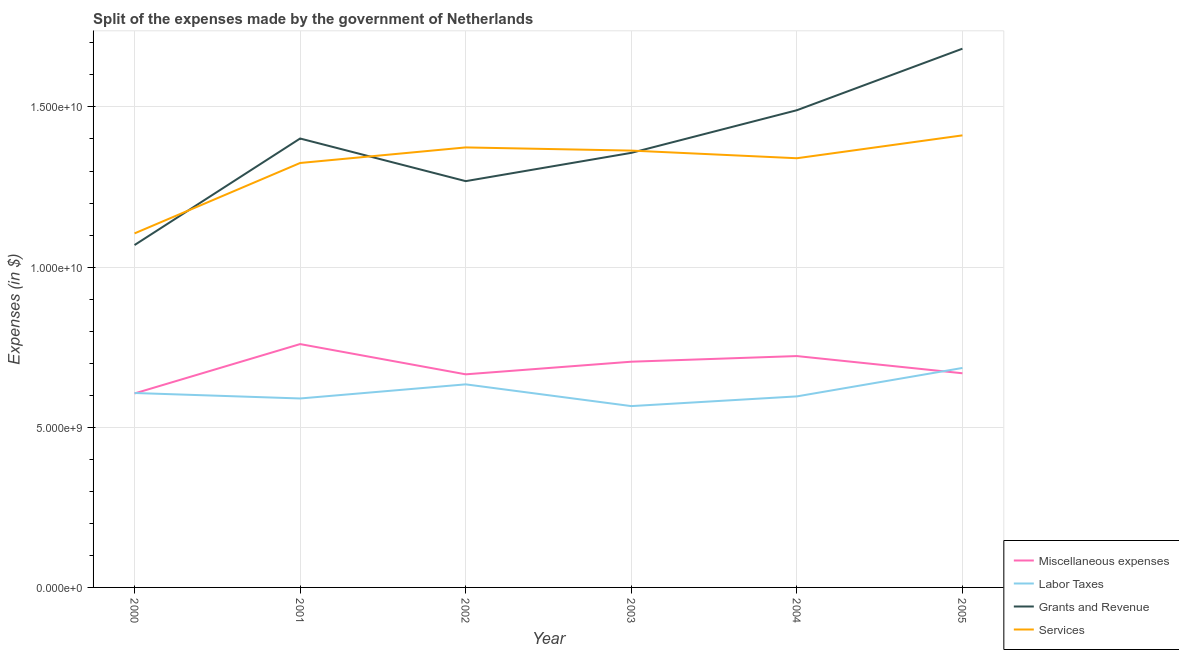Does the line corresponding to amount spent on labor taxes intersect with the line corresponding to amount spent on grants and revenue?
Provide a short and direct response. No. What is the amount spent on grants and revenue in 2005?
Your response must be concise. 1.68e+1. Across all years, what is the maximum amount spent on labor taxes?
Offer a very short reply. 6.85e+09. Across all years, what is the minimum amount spent on services?
Offer a terse response. 1.11e+1. What is the total amount spent on miscellaneous expenses in the graph?
Give a very brief answer. 4.13e+1. What is the difference between the amount spent on miscellaneous expenses in 2001 and that in 2002?
Keep it short and to the point. 9.44e+08. What is the difference between the amount spent on services in 2001 and the amount spent on miscellaneous expenses in 2003?
Offer a very short reply. 6.20e+09. What is the average amount spent on grants and revenue per year?
Keep it short and to the point. 1.38e+1. In the year 2003, what is the difference between the amount spent on labor taxes and amount spent on grants and revenue?
Make the answer very short. -7.91e+09. In how many years, is the amount spent on grants and revenue greater than 11000000000 $?
Your answer should be very brief. 5. What is the ratio of the amount spent on grants and revenue in 2001 to that in 2003?
Make the answer very short. 1.03. Is the amount spent on miscellaneous expenses in 2001 less than that in 2004?
Make the answer very short. No. What is the difference between the highest and the second highest amount spent on grants and revenue?
Make the answer very short. 1.92e+09. What is the difference between the highest and the lowest amount spent on grants and revenue?
Offer a terse response. 6.13e+09. Is the sum of the amount spent on labor taxes in 2001 and 2002 greater than the maximum amount spent on services across all years?
Provide a short and direct response. No. Is it the case that in every year, the sum of the amount spent on services and amount spent on grants and revenue is greater than the sum of amount spent on miscellaneous expenses and amount spent on labor taxes?
Give a very brief answer. Yes. Is it the case that in every year, the sum of the amount spent on miscellaneous expenses and amount spent on labor taxes is greater than the amount spent on grants and revenue?
Give a very brief answer. No. Does the graph contain any zero values?
Make the answer very short. No. What is the title of the graph?
Make the answer very short. Split of the expenses made by the government of Netherlands. Does "Belgium" appear as one of the legend labels in the graph?
Ensure brevity in your answer.  No. What is the label or title of the X-axis?
Your answer should be compact. Year. What is the label or title of the Y-axis?
Your response must be concise. Expenses (in $). What is the Expenses (in $) of Miscellaneous expenses in 2000?
Provide a short and direct response. 6.06e+09. What is the Expenses (in $) of Labor Taxes in 2000?
Your answer should be very brief. 6.07e+09. What is the Expenses (in $) in Grants and Revenue in 2000?
Offer a terse response. 1.07e+1. What is the Expenses (in $) of Services in 2000?
Offer a terse response. 1.11e+1. What is the Expenses (in $) in Miscellaneous expenses in 2001?
Your answer should be very brief. 7.60e+09. What is the Expenses (in $) of Labor Taxes in 2001?
Your answer should be compact. 5.90e+09. What is the Expenses (in $) of Grants and Revenue in 2001?
Offer a terse response. 1.40e+1. What is the Expenses (in $) of Services in 2001?
Ensure brevity in your answer.  1.33e+1. What is the Expenses (in $) in Miscellaneous expenses in 2002?
Provide a succinct answer. 6.65e+09. What is the Expenses (in $) of Labor Taxes in 2002?
Offer a terse response. 6.34e+09. What is the Expenses (in $) of Grants and Revenue in 2002?
Make the answer very short. 1.27e+1. What is the Expenses (in $) in Services in 2002?
Provide a short and direct response. 1.37e+1. What is the Expenses (in $) in Miscellaneous expenses in 2003?
Your response must be concise. 7.05e+09. What is the Expenses (in $) in Labor Taxes in 2003?
Give a very brief answer. 5.66e+09. What is the Expenses (in $) of Grants and Revenue in 2003?
Make the answer very short. 1.36e+1. What is the Expenses (in $) in Services in 2003?
Provide a succinct answer. 1.36e+1. What is the Expenses (in $) in Miscellaneous expenses in 2004?
Make the answer very short. 7.22e+09. What is the Expenses (in $) in Labor Taxes in 2004?
Provide a succinct answer. 5.96e+09. What is the Expenses (in $) of Grants and Revenue in 2004?
Your answer should be very brief. 1.49e+1. What is the Expenses (in $) of Services in 2004?
Keep it short and to the point. 1.34e+1. What is the Expenses (in $) in Miscellaneous expenses in 2005?
Your response must be concise. 6.69e+09. What is the Expenses (in $) in Labor Taxes in 2005?
Provide a succinct answer. 6.85e+09. What is the Expenses (in $) in Grants and Revenue in 2005?
Your response must be concise. 1.68e+1. What is the Expenses (in $) in Services in 2005?
Offer a terse response. 1.41e+1. Across all years, what is the maximum Expenses (in $) of Miscellaneous expenses?
Ensure brevity in your answer.  7.60e+09. Across all years, what is the maximum Expenses (in $) in Labor Taxes?
Ensure brevity in your answer.  6.85e+09. Across all years, what is the maximum Expenses (in $) of Grants and Revenue?
Your answer should be compact. 1.68e+1. Across all years, what is the maximum Expenses (in $) of Services?
Make the answer very short. 1.41e+1. Across all years, what is the minimum Expenses (in $) in Miscellaneous expenses?
Your answer should be very brief. 6.06e+09. Across all years, what is the minimum Expenses (in $) of Labor Taxes?
Keep it short and to the point. 5.66e+09. Across all years, what is the minimum Expenses (in $) in Grants and Revenue?
Provide a short and direct response. 1.07e+1. Across all years, what is the minimum Expenses (in $) of Services?
Provide a short and direct response. 1.11e+1. What is the total Expenses (in $) in Miscellaneous expenses in the graph?
Provide a succinct answer. 4.13e+1. What is the total Expenses (in $) of Labor Taxes in the graph?
Offer a terse response. 3.68e+1. What is the total Expenses (in $) of Grants and Revenue in the graph?
Offer a terse response. 8.27e+1. What is the total Expenses (in $) in Services in the graph?
Your answer should be compact. 7.92e+1. What is the difference between the Expenses (in $) of Miscellaneous expenses in 2000 and that in 2001?
Your answer should be very brief. -1.54e+09. What is the difference between the Expenses (in $) of Labor Taxes in 2000 and that in 2001?
Your answer should be very brief. 1.71e+08. What is the difference between the Expenses (in $) in Grants and Revenue in 2000 and that in 2001?
Provide a short and direct response. -3.33e+09. What is the difference between the Expenses (in $) of Services in 2000 and that in 2001?
Offer a very short reply. -2.20e+09. What is the difference between the Expenses (in $) of Miscellaneous expenses in 2000 and that in 2002?
Offer a terse response. -5.97e+08. What is the difference between the Expenses (in $) in Labor Taxes in 2000 and that in 2002?
Provide a short and direct response. -2.70e+08. What is the difference between the Expenses (in $) in Grants and Revenue in 2000 and that in 2002?
Offer a terse response. -2.00e+09. What is the difference between the Expenses (in $) in Services in 2000 and that in 2002?
Provide a succinct answer. -2.68e+09. What is the difference between the Expenses (in $) in Miscellaneous expenses in 2000 and that in 2003?
Offer a very short reply. -9.91e+08. What is the difference between the Expenses (in $) in Labor Taxes in 2000 and that in 2003?
Ensure brevity in your answer.  4.09e+08. What is the difference between the Expenses (in $) in Grants and Revenue in 2000 and that in 2003?
Your answer should be very brief. -2.88e+09. What is the difference between the Expenses (in $) of Services in 2000 and that in 2003?
Offer a terse response. -2.58e+09. What is the difference between the Expenses (in $) in Miscellaneous expenses in 2000 and that in 2004?
Keep it short and to the point. -1.17e+09. What is the difference between the Expenses (in $) of Labor Taxes in 2000 and that in 2004?
Make the answer very short. 1.06e+08. What is the difference between the Expenses (in $) in Grants and Revenue in 2000 and that in 2004?
Your answer should be compact. -4.21e+09. What is the difference between the Expenses (in $) in Services in 2000 and that in 2004?
Provide a short and direct response. -2.35e+09. What is the difference between the Expenses (in $) of Miscellaneous expenses in 2000 and that in 2005?
Provide a succinct answer. -6.30e+08. What is the difference between the Expenses (in $) in Labor Taxes in 2000 and that in 2005?
Your answer should be very brief. -7.82e+08. What is the difference between the Expenses (in $) in Grants and Revenue in 2000 and that in 2005?
Your response must be concise. -6.13e+09. What is the difference between the Expenses (in $) in Services in 2000 and that in 2005?
Offer a terse response. -3.06e+09. What is the difference between the Expenses (in $) in Miscellaneous expenses in 2001 and that in 2002?
Provide a succinct answer. 9.44e+08. What is the difference between the Expenses (in $) of Labor Taxes in 2001 and that in 2002?
Make the answer very short. -4.41e+08. What is the difference between the Expenses (in $) of Grants and Revenue in 2001 and that in 2002?
Make the answer very short. 1.33e+09. What is the difference between the Expenses (in $) of Services in 2001 and that in 2002?
Offer a very short reply. -4.86e+08. What is the difference between the Expenses (in $) of Miscellaneous expenses in 2001 and that in 2003?
Your response must be concise. 5.50e+08. What is the difference between the Expenses (in $) of Labor Taxes in 2001 and that in 2003?
Keep it short and to the point. 2.38e+08. What is the difference between the Expenses (in $) in Grants and Revenue in 2001 and that in 2003?
Your response must be concise. 4.48e+08. What is the difference between the Expenses (in $) of Services in 2001 and that in 2003?
Keep it short and to the point. -3.87e+08. What is the difference between the Expenses (in $) of Miscellaneous expenses in 2001 and that in 2004?
Your answer should be very brief. 3.74e+08. What is the difference between the Expenses (in $) in Labor Taxes in 2001 and that in 2004?
Ensure brevity in your answer.  -6.50e+07. What is the difference between the Expenses (in $) of Grants and Revenue in 2001 and that in 2004?
Keep it short and to the point. -8.83e+08. What is the difference between the Expenses (in $) of Services in 2001 and that in 2004?
Offer a terse response. -1.48e+08. What is the difference between the Expenses (in $) of Miscellaneous expenses in 2001 and that in 2005?
Your answer should be compact. 9.11e+08. What is the difference between the Expenses (in $) of Labor Taxes in 2001 and that in 2005?
Keep it short and to the point. -9.53e+08. What is the difference between the Expenses (in $) in Grants and Revenue in 2001 and that in 2005?
Your response must be concise. -2.80e+09. What is the difference between the Expenses (in $) of Services in 2001 and that in 2005?
Give a very brief answer. -8.62e+08. What is the difference between the Expenses (in $) of Miscellaneous expenses in 2002 and that in 2003?
Your response must be concise. -3.94e+08. What is the difference between the Expenses (in $) of Labor Taxes in 2002 and that in 2003?
Offer a terse response. 6.79e+08. What is the difference between the Expenses (in $) of Grants and Revenue in 2002 and that in 2003?
Your answer should be compact. -8.83e+08. What is the difference between the Expenses (in $) in Services in 2002 and that in 2003?
Give a very brief answer. 9.90e+07. What is the difference between the Expenses (in $) in Miscellaneous expenses in 2002 and that in 2004?
Provide a short and direct response. -5.70e+08. What is the difference between the Expenses (in $) of Labor Taxes in 2002 and that in 2004?
Your answer should be compact. 3.76e+08. What is the difference between the Expenses (in $) in Grants and Revenue in 2002 and that in 2004?
Keep it short and to the point. -2.21e+09. What is the difference between the Expenses (in $) in Services in 2002 and that in 2004?
Provide a short and direct response. 3.38e+08. What is the difference between the Expenses (in $) of Miscellaneous expenses in 2002 and that in 2005?
Offer a terse response. -3.30e+07. What is the difference between the Expenses (in $) in Labor Taxes in 2002 and that in 2005?
Your answer should be very brief. -5.12e+08. What is the difference between the Expenses (in $) of Grants and Revenue in 2002 and that in 2005?
Make the answer very short. -4.14e+09. What is the difference between the Expenses (in $) in Services in 2002 and that in 2005?
Offer a very short reply. -3.76e+08. What is the difference between the Expenses (in $) in Miscellaneous expenses in 2003 and that in 2004?
Give a very brief answer. -1.76e+08. What is the difference between the Expenses (in $) in Labor Taxes in 2003 and that in 2004?
Your response must be concise. -3.03e+08. What is the difference between the Expenses (in $) in Grants and Revenue in 2003 and that in 2004?
Offer a very short reply. -1.33e+09. What is the difference between the Expenses (in $) in Services in 2003 and that in 2004?
Keep it short and to the point. 2.39e+08. What is the difference between the Expenses (in $) of Miscellaneous expenses in 2003 and that in 2005?
Provide a short and direct response. 3.61e+08. What is the difference between the Expenses (in $) of Labor Taxes in 2003 and that in 2005?
Give a very brief answer. -1.19e+09. What is the difference between the Expenses (in $) of Grants and Revenue in 2003 and that in 2005?
Provide a short and direct response. -3.25e+09. What is the difference between the Expenses (in $) in Services in 2003 and that in 2005?
Your answer should be very brief. -4.75e+08. What is the difference between the Expenses (in $) in Miscellaneous expenses in 2004 and that in 2005?
Give a very brief answer. 5.37e+08. What is the difference between the Expenses (in $) in Labor Taxes in 2004 and that in 2005?
Provide a short and direct response. -8.88e+08. What is the difference between the Expenses (in $) in Grants and Revenue in 2004 and that in 2005?
Give a very brief answer. -1.92e+09. What is the difference between the Expenses (in $) in Services in 2004 and that in 2005?
Provide a short and direct response. -7.14e+08. What is the difference between the Expenses (in $) of Miscellaneous expenses in 2000 and the Expenses (in $) of Labor Taxes in 2001?
Provide a succinct answer. 1.57e+08. What is the difference between the Expenses (in $) in Miscellaneous expenses in 2000 and the Expenses (in $) in Grants and Revenue in 2001?
Provide a short and direct response. -7.96e+09. What is the difference between the Expenses (in $) of Miscellaneous expenses in 2000 and the Expenses (in $) of Services in 2001?
Keep it short and to the point. -7.20e+09. What is the difference between the Expenses (in $) in Labor Taxes in 2000 and the Expenses (in $) in Grants and Revenue in 2001?
Your answer should be compact. -7.94e+09. What is the difference between the Expenses (in $) in Labor Taxes in 2000 and the Expenses (in $) in Services in 2001?
Your answer should be compact. -7.18e+09. What is the difference between the Expenses (in $) in Grants and Revenue in 2000 and the Expenses (in $) in Services in 2001?
Provide a succinct answer. -2.56e+09. What is the difference between the Expenses (in $) in Miscellaneous expenses in 2000 and the Expenses (in $) in Labor Taxes in 2002?
Provide a short and direct response. -2.84e+08. What is the difference between the Expenses (in $) in Miscellaneous expenses in 2000 and the Expenses (in $) in Grants and Revenue in 2002?
Your answer should be very brief. -6.63e+09. What is the difference between the Expenses (in $) in Miscellaneous expenses in 2000 and the Expenses (in $) in Services in 2002?
Offer a very short reply. -7.68e+09. What is the difference between the Expenses (in $) of Labor Taxes in 2000 and the Expenses (in $) of Grants and Revenue in 2002?
Your response must be concise. -6.61e+09. What is the difference between the Expenses (in $) in Labor Taxes in 2000 and the Expenses (in $) in Services in 2002?
Your response must be concise. -7.67e+09. What is the difference between the Expenses (in $) of Grants and Revenue in 2000 and the Expenses (in $) of Services in 2002?
Keep it short and to the point. -3.05e+09. What is the difference between the Expenses (in $) in Miscellaneous expenses in 2000 and the Expenses (in $) in Labor Taxes in 2003?
Offer a terse response. 3.95e+08. What is the difference between the Expenses (in $) of Miscellaneous expenses in 2000 and the Expenses (in $) of Grants and Revenue in 2003?
Ensure brevity in your answer.  -7.51e+09. What is the difference between the Expenses (in $) in Miscellaneous expenses in 2000 and the Expenses (in $) in Services in 2003?
Your answer should be very brief. -7.58e+09. What is the difference between the Expenses (in $) of Labor Taxes in 2000 and the Expenses (in $) of Grants and Revenue in 2003?
Provide a succinct answer. -7.50e+09. What is the difference between the Expenses (in $) of Labor Taxes in 2000 and the Expenses (in $) of Services in 2003?
Offer a very short reply. -7.57e+09. What is the difference between the Expenses (in $) of Grants and Revenue in 2000 and the Expenses (in $) of Services in 2003?
Your answer should be very brief. -2.95e+09. What is the difference between the Expenses (in $) of Miscellaneous expenses in 2000 and the Expenses (in $) of Labor Taxes in 2004?
Make the answer very short. 9.20e+07. What is the difference between the Expenses (in $) in Miscellaneous expenses in 2000 and the Expenses (in $) in Grants and Revenue in 2004?
Ensure brevity in your answer.  -8.84e+09. What is the difference between the Expenses (in $) of Miscellaneous expenses in 2000 and the Expenses (in $) of Services in 2004?
Offer a very short reply. -7.34e+09. What is the difference between the Expenses (in $) of Labor Taxes in 2000 and the Expenses (in $) of Grants and Revenue in 2004?
Your answer should be very brief. -8.83e+09. What is the difference between the Expenses (in $) of Labor Taxes in 2000 and the Expenses (in $) of Services in 2004?
Provide a short and direct response. -7.33e+09. What is the difference between the Expenses (in $) in Grants and Revenue in 2000 and the Expenses (in $) in Services in 2004?
Give a very brief answer. -2.71e+09. What is the difference between the Expenses (in $) in Miscellaneous expenses in 2000 and the Expenses (in $) in Labor Taxes in 2005?
Your answer should be very brief. -7.96e+08. What is the difference between the Expenses (in $) in Miscellaneous expenses in 2000 and the Expenses (in $) in Grants and Revenue in 2005?
Provide a short and direct response. -1.08e+1. What is the difference between the Expenses (in $) in Miscellaneous expenses in 2000 and the Expenses (in $) in Services in 2005?
Make the answer very short. -8.06e+09. What is the difference between the Expenses (in $) of Labor Taxes in 2000 and the Expenses (in $) of Grants and Revenue in 2005?
Offer a very short reply. -1.07e+1. What is the difference between the Expenses (in $) of Labor Taxes in 2000 and the Expenses (in $) of Services in 2005?
Make the answer very short. -8.04e+09. What is the difference between the Expenses (in $) of Grants and Revenue in 2000 and the Expenses (in $) of Services in 2005?
Give a very brief answer. -3.42e+09. What is the difference between the Expenses (in $) of Miscellaneous expenses in 2001 and the Expenses (in $) of Labor Taxes in 2002?
Offer a terse response. 1.26e+09. What is the difference between the Expenses (in $) of Miscellaneous expenses in 2001 and the Expenses (in $) of Grants and Revenue in 2002?
Offer a very short reply. -5.09e+09. What is the difference between the Expenses (in $) in Miscellaneous expenses in 2001 and the Expenses (in $) in Services in 2002?
Provide a short and direct response. -6.14e+09. What is the difference between the Expenses (in $) of Labor Taxes in 2001 and the Expenses (in $) of Grants and Revenue in 2002?
Give a very brief answer. -6.78e+09. What is the difference between the Expenses (in $) of Labor Taxes in 2001 and the Expenses (in $) of Services in 2002?
Ensure brevity in your answer.  -7.84e+09. What is the difference between the Expenses (in $) in Grants and Revenue in 2001 and the Expenses (in $) in Services in 2002?
Make the answer very short. 2.78e+08. What is the difference between the Expenses (in $) of Miscellaneous expenses in 2001 and the Expenses (in $) of Labor Taxes in 2003?
Make the answer very short. 1.94e+09. What is the difference between the Expenses (in $) of Miscellaneous expenses in 2001 and the Expenses (in $) of Grants and Revenue in 2003?
Provide a short and direct response. -5.97e+09. What is the difference between the Expenses (in $) of Miscellaneous expenses in 2001 and the Expenses (in $) of Services in 2003?
Give a very brief answer. -6.04e+09. What is the difference between the Expenses (in $) of Labor Taxes in 2001 and the Expenses (in $) of Grants and Revenue in 2003?
Make the answer very short. -7.67e+09. What is the difference between the Expenses (in $) in Labor Taxes in 2001 and the Expenses (in $) in Services in 2003?
Ensure brevity in your answer.  -7.74e+09. What is the difference between the Expenses (in $) of Grants and Revenue in 2001 and the Expenses (in $) of Services in 2003?
Make the answer very short. 3.77e+08. What is the difference between the Expenses (in $) of Miscellaneous expenses in 2001 and the Expenses (in $) of Labor Taxes in 2004?
Your answer should be compact. 1.63e+09. What is the difference between the Expenses (in $) of Miscellaneous expenses in 2001 and the Expenses (in $) of Grants and Revenue in 2004?
Your answer should be very brief. -7.30e+09. What is the difference between the Expenses (in $) in Miscellaneous expenses in 2001 and the Expenses (in $) in Services in 2004?
Your response must be concise. -5.80e+09. What is the difference between the Expenses (in $) in Labor Taxes in 2001 and the Expenses (in $) in Grants and Revenue in 2004?
Your answer should be compact. -9.00e+09. What is the difference between the Expenses (in $) of Labor Taxes in 2001 and the Expenses (in $) of Services in 2004?
Give a very brief answer. -7.50e+09. What is the difference between the Expenses (in $) of Grants and Revenue in 2001 and the Expenses (in $) of Services in 2004?
Make the answer very short. 6.16e+08. What is the difference between the Expenses (in $) of Miscellaneous expenses in 2001 and the Expenses (in $) of Labor Taxes in 2005?
Offer a terse response. 7.45e+08. What is the difference between the Expenses (in $) of Miscellaneous expenses in 2001 and the Expenses (in $) of Grants and Revenue in 2005?
Provide a short and direct response. -9.22e+09. What is the difference between the Expenses (in $) of Miscellaneous expenses in 2001 and the Expenses (in $) of Services in 2005?
Your answer should be very brief. -6.52e+09. What is the difference between the Expenses (in $) in Labor Taxes in 2001 and the Expenses (in $) in Grants and Revenue in 2005?
Keep it short and to the point. -1.09e+1. What is the difference between the Expenses (in $) of Labor Taxes in 2001 and the Expenses (in $) of Services in 2005?
Ensure brevity in your answer.  -8.21e+09. What is the difference between the Expenses (in $) of Grants and Revenue in 2001 and the Expenses (in $) of Services in 2005?
Keep it short and to the point. -9.80e+07. What is the difference between the Expenses (in $) of Miscellaneous expenses in 2002 and the Expenses (in $) of Labor Taxes in 2003?
Keep it short and to the point. 9.92e+08. What is the difference between the Expenses (in $) of Miscellaneous expenses in 2002 and the Expenses (in $) of Grants and Revenue in 2003?
Provide a short and direct response. -6.91e+09. What is the difference between the Expenses (in $) in Miscellaneous expenses in 2002 and the Expenses (in $) in Services in 2003?
Provide a succinct answer. -6.98e+09. What is the difference between the Expenses (in $) of Labor Taxes in 2002 and the Expenses (in $) of Grants and Revenue in 2003?
Your answer should be very brief. -7.23e+09. What is the difference between the Expenses (in $) in Labor Taxes in 2002 and the Expenses (in $) in Services in 2003?
Give a very brief answer. -7.30e+09. What is the difference between the Expenses (in $) in Grants and Revenue in 2002 and the Expenses (in $) in Services in 2003?
Provide a succinct answer. -9.54e+08. What is the difference between the Expenses (in $) of Miscellaneous expenses in 2002 and the Expenses (in $) of Labor Taxes in 2004?
Keep it short and to the point. 6.89e+08. What is the difference between the Expenses (in $) in Miscellaneous expenses in 2002 and the Expenses (in $) in Grants and Revenue in 2004?
Give a very brief answer. -8.24e+09. What is the difference between the Expenses (in $) in Miscellaneous expenses in 2002 and the Expenses (in $) in Services in 2004?
Provide a short and direct response. -6.75e+09. What is the difference between the Expenses (in $) of Labor Taxes in 2002 and the Expenses (in $) of Grants and Revenue in 2004?
Your answer should be very brief. -8.56e+09. What is the difference between the Expenses (in $) in Labor Taxes in 2002 and the Expenses (in $) in Services in 2004?
Provide a succinct answer. -7.06e+09. What is the difference between the Expenses (in $) of Grants and Revenue in 2002 and the Expenses (in $) of Services in 2004?
Provide a short and direct response. -7.15e+08. What is the difference between the Expenses (in $) of Miscellaneous expenses in 2002 and the Expenses (in $) of Labor Taxes in 2005?
Your answer should be compact. -1.99e+08. What is the difference between the Expenses (in $) of Miscellaneous expenses in 2002 and the Expenses (in $) of Grants and Revenue in 2005?
Give a very brief answer. -1.02e+1. What is the difference between the Expenses (in $) of Miscellaneous expenses in 2002 and the Expenses (in $) of Services in 2005?
Your answer should be very brief. -7.46e+09. What is the difference between the Expenses (in $) of Labor Taxes in 2002 and the Expenses (in $) of Grants and Revenue in 2005?
Your response must be concise. -1.05e+1. What is the difference between the Expenses (in $) in Labor Taxes in 2002 and the Expenses (in $) in Services in 2005?
Ensure brevity in your answer.  -7.77e+09. What is the difference between the Expenses (in $) of Grants and Revenue in 2002 and the Expenses (in $) of Services in 2005?
Make the answer very short. -1.43e+09. What is the difference between the Expenses (in $) in Miscellaneous expenses in 2003 and the Expenses (in $) in Labor Taxes in 2004?
Give a very brief answer. 1.08e+09. What is the difference between the Expenses (in $) in Miscellaneous expenses in 2003 and the Expenses (in $) in Grants and Revenue in 2004?
Provide a short and direct response. -7.85e+09. What is the difference between the Expenses (in $) of Miscellaneous expenses in 2003 and the Expenses (in $) of Services in 2004?
Provide a succinct answer. -6.35e+09. What is the difference between the Expenses (in $) of Labor Taxes in 2003 and the Expenses (in $) of Grants and Revenue in 2004?
Your response must be concise. -9.24e+09. What is the difference between the Expenses (in $) of Labor Taxes in 2003 and the Expenses (in $) of Services in 2004?
Your answer should be compact. -7.74e+09. What is the difference between the Expenses (in $) in Grants and Revenue in 2003 and the Expenses (in $) in Services in 2004?
Provide a short and direct response. 1.68e+08. What is the difference between the Expenses (in $) of Miscellaneous expenses in 2003 and the Expenses (in $) of Labor Taxes in 2005?
Your response must be concise. 1.95e+08. What is the difference between the Expenses (in $) in Miscellaneous expenses in 2003 and the Expenses (in $) in Grants and Revenue in 2005?
Keep it short and to the point. -9.77e+09. What is the difference between the Expenses (in $) in Miscellaneous expenses in 2003 and the Expenses (in $) in Services in 2005?
Your response must be concise. -7.07e+09. What is the difference between the Expenses (in $) in Labor Taxes in 2003 and the Expenses (in $) in Grants and Revenue in 2005?
Your response must be concise. -1.12e+1. What is the difference between the Expenses (in $) of Labor Taxes in 2003 and the Expenses (in $) of Services in 2005?
Offer a very short reply. -8.45e+09. What is the difference between the Expenses (in $) of Grants and Revenue in 2003 and the Expenses (in $) of Services in 2005?
Provide a short and direct response. -5.46e+08. What is the difference between the Expenses (in $) in Miscellaneous expenses in 2004 and the Expenses (in $) in Labor Taxes in 2005?
Your response must be concise. 3.71e+08. What is the difference between the Expenses (in $) in Miscellaneous expenses in 2004 and the Expenses (in $) in Grants and Revenue in 2005?
Your answer should be compact. -9.60e+09. What is the difference between the Expenses (in $) in Miscellaneous expenses in 2004 and the Expenses (in $) in Services in 2005?
Provide a short and direct response. -6.89e+09. What is the difference between the Expenses (in $) of Labor Taxes in 2004 and the Expenses (in $) of Grants and Revenue in 2005?
Provide a succinct answer. -1.09e+1. What is the difference between the Expenses (in $) of Labor Taxes in 2004 and the Expenses (in $) of Services in 2005?
Keep it short and to the point. -8.15e+09. What is the difference between the Expenses (in $) of Grants and Revenue in 2004 and the Expenses (in $) of Services in 2005?
Provide a short and direct response. 7.85e+08. What is the average Expenses (in $) in Miscellaneous expenses per year?
Your answer should be very brief. 6.88e+09. What is the average Expenses (in $) of Labor Taxes per year?
Give a very brief answer. 6.13e+09. What is the average Expenses (in $) of Grants and Revenue per year?
Offer a very short reply. 1.38e+1. What is the average Expenses (in $) of Services per year?
Your answer should be very brief. 1.32e+1. In the year 2000, what is the difference between the Expenses (in $) in Miscellaneous expenses and Expenses (in $) in Labor Taxes?
Your answer should be very brief. -1.40e+07. In the year 2000, what is the difference between the Expenses (in $) in Miscellaneous expenses and Expenses (in $) in Grants and Revenue?
Your answer should be very brief. -4.63e+09. In the year 2000, what is the difference between the Expenses (in $) of Miscellaneous expenses and Expenses (in $) of Services?
Provide a short and direct response. -5.00e+09. In the year 2000, what is the difference between the Expenses (in $) of Labor Taxes and Expenses (in $) of Grants and Revenue?
Ensure brevity in your answer.  -4.62e+09. In the year 2000, what is the difference between the Expenses (in $) in Labor Taxes and Expenses (in $) in Services?
Ensure brevity in your answer.  -4.98e+09. In the year 2000, what is the difference between the Expenses (in $) of Grants and Revenue and Expenses (in $) of Services?
Offer a very short reply. -3.64e+08. In the year 2001, what is the difference between the Expenses (in $) in Miscellaneous expenses and Expenses (in $) in Labor Taxes?
Make the answer very short. 1.70e+09. In the year 2001, what is the difference between the Expenses (in $) of Miscellaneous expenses and Expenses (in $) of Grants and Revenue?
Your answer should be compact. -6.42e+09. In the year 2001, what is the difference between the Expenses (in $) of Miscellaneous expenses and Expenses (in $) of Services?
Offer a very short reply. -5.65e+09. In the year 2001, what is the difference between the Expenses (in $) of Labor Taxes and Expenses (in $) of Grants and Revenue?
Your answer should be compact. -8.12e+09. In the year 2001, what is the difference between the Expenses (in $) of Labor Taxes and Expenses (in $) of Services?
Ensure brevity in your answer.  -7.35e+09. In the year 2001, what is the difference between the Expenses (in $) of Grants and Revenue and Expenses (in $) of Services?
Offer a very short reply. 7.64e+08. In the year 2002, what is the difference between the Expenses (in $) in Miscellaneous expenses and Expenses (in $) in Labor Taxes?
Your answer should be very brief. 3.13e+08. In the year 2002, what is the difference between the Expenses (in $) of Miscellaneous expenses and Expenses (in $) of Grants and Revenue?
Offer a terse response. -6.03e+09. In the year 2002, what is the difference between the Expenses (in $) of Miscellaneous expenses and Expenses (in $) of Services?
Keep it short and to the point. -7.08e+09. In the year 2002, what is the difference between the Expenses (in $) of Labor Taxes and Expenses (in $) of Grants and Revenue?
Your answer should be very brief. -6.34e+09. In the year 2002, what is the difference between the Expenses (in $) in Labor Taxes and Expenses (in $) in Services?
Provide a short and direct response. -7.40e+09. In the year 2002, what is the difference between the Expenses (in $) of Grants and Revenue and Expenses (in $) of Services?
Offer a very short reply. -1.05e+09. In the year 2003, what is the difference between the Expenses (in $) of Miscellaneous expenses and Expenses (in $) of Labor Taxes?
Provide a short and direct response. 1.39e+09. In the year 2003, what is the difference between the Expenses (in $) in Miscellaneous expenses and Expenses (in $) in Grants and Revenue?
Ensure brevity in your answer.  -6.52e+09. In the year 2003, what is the difference between the Expenses (in $) of Miscellaneous expenses and Expenses (in $) of Services?
Provide a succinct answer. -6.59e+09. In the year 2003, what is the difference between the Expenses (in $) in Labor Taxes and Expenses (in $) in Grants and Revenue?
Ensure brevity in your answer.  -7.91e+09. In the year 2003, what is the difference between the Expenses (in $) in Labor Taxes and Expenses (in $) in Services?
Offer a terse response. -7.98e+09. In the year 2003, what is the difference between the Expenses (in $) of Grants and Revenue and Expenses (in $) of Services?
Your response must be concise. -7.10e+07. In the year 2004, what is the difference between the Expenses (in $) in Miscellaneous expenses and Expenses (in $) in Labor Taxes?
Make the answer very short. 1.26e+09. In the year 2004, what is the difference between the Expenses (in $) of Miscellaneous expenses and Expenses (in $) of Grants and Revenue?
Offer a very short reply. -7.68e+09. In the year 2004, what is the difference between the Expenses (in $) in Miscellaneous expenses and Expenses (in $) in Services?
Offer a very short reply. -6.18e+09. In the year 2004, what is the difference between the Expenses (in $) in Labor Taxes and Expenses (in $) in Grants and Revenue?
Offer a terse response. -8.93e+09. In the year 2004, what is the difference between the Expenses (in $) in Labor Taxes and Expenses (in $) in Services?
Provide a succinct answer. -7.44e+09. In the year 2004, what is the difference between the Expenses (in $) of Grants and Revenue and Expenses (in $) of Services?
Provide a succinct answer. 1.50e+09. In the year 2005, what is the difference between the Expenses (in $) of Miscellaneous expenses and Expenses (in $) of Labor Taxes?
Give a very brief answer. -1.66e+08. In the year 2005, what is the difference between the Expenses (in $) in Miscellaneous expenses and Expenses (in $) in Grants and Revenue?
Offer a terse response. -1.01e+1. In the year 2005, what is the difference between the Expenses (in $) in Miscellaneous expenses and Expenses (in $) in Services?
Give a very brief answer. -7.43e+09. In the year 2005, what is the difference between the Expenses (in $) in Labor Taxes and Expenses (in $) in Grants and Revenue?
Make the answer very short. -9.97e+09. In the year 2005, what is the difference between the Expenses (in $) of Labor Taxes and Expenses (in $) of Services?
Offer a terse response. -7.26e+09. In the year 2005, what is the difference between the Expenses (in $) in Grants and Revenue and Expenses (in $) in Services?
Your answer should be compact. 2.71e+09. What is the ratio of the Expenses (in $) of Miscellaneous expenses in 2000 to that in 2001?
Provide a short and direct response. 0.8. What is the ratio of the Expenses (in $) of Grants and Revenue in 2000 to that in 2001?
Ensure brevity in your answer.  0.76. What is the ratio of the Expenses (in $) of Services in 2000 to that in 2001?
Give a very brief answer. 0.83. What is the ratio of the Expenses (in $) of Miscellaneous expenses in 2000 to that in 2002?
Offer a terse response. 0.91. What is the ratio of the Expenses (in $) of Labor Taxes in 2000 to that in 2002?
Give a very brief answer. 0.96. What is the ratio of the Expenses (in $) of Grants and Revenue in 2000 to that in 2002?
Provide a succinct answer. 0.84. What is the ratio of the Expenses (in $) in Services in 2000 to that in 2002?
Make the answer very short. 0.8. What is the ratio of the Expenses (in $) of Miscellaneous expenses in 2000 to that in 2003?
Your answer should be compact. 0.86. What is the ratio of the Expenses (in $) of Labor Taxes in 2000 to that in 2003?
Offer a very short reply. 1.07. What is the ratio of the Expenses (in $) in Grants and Revenue in 2000 to that in 2003?
Offer a terse response. 0.79. What is the ratio of the Expenses (in $) in Services in 2000 to that in 2003?
Ensure brevity in your answer.  0.81. What is the ratio of the Expenses (in $) of Miscellaneous expenses in 2000 to that in 2004?
Offer a terse response. 0.84. What is the ratio of the Expenses (in $) in Labor Taxes in 2000 to that in 2004?
Ensure brevity in your answer.  1.02. What is the ratio of the Expenses (in $) of Grants and Revenue in 2000 to that in 2004?
Keep it short and to the point. 0.72. What is the ratio of the Expenses (in $) of Services in 2000 to that in 2004?
Make the answer very short. 0.82. What is the ratio of the Expenses (in $) of Miscellaneous expenses in 2000 to that in 2005?
Give a very brief answer. 0.91. What is the ratio of the Expenses (in $) of Labor Taxes in 2000 to that in 2005?
Keep it short and to the point. 0.89. What is the ratio of the Expenses (in $) in Grants and Revenue in 2000 to that in 2005?
Ensure brevity in your answer.  0.64. What is the ratio of the Expenses (in $) in Services in 2000 to that in 2005?
Your answer should be very brief. 0.78. What is the ratio of the Expenses (in $) in Miscellaneous expenses in 2001 to that in 2002?
Keep it short and to the point. 1.14. What is the ratio of the Expenses (in $) of Labor Taxes in 2001 to that in 2002?
Provide a short and direct response. 0.93. What is the ratio of the Expenses (in $) of Grants and Revenue in 2001 to that in 2002?
Offer a very short reply. 1.1. What is the ratio of the Expenses (in $) in Services in 2001 to that in 2002?
Make the answer very short. 0.96. What is the ratio of the Expenses (in $) of Miscellaneous expenses in 2001 to that in 2003?
Your answer should be compact. 1.08. What is the ratio of the Expenses (in $) in Labor Taxes in 2001 to that in 2003?
Ensure brevity in your answer.  1.04. What is the ratio of the Expenses (in $) in Grants and Revenue in 2001 to that in 2003?
Keep it short and to the point. 1.03. What is the ratio of the Expenses (in $) of Services in 2001 to that in 2003?
Your answer should be compact. 0.97. What is the ratio of the Expenses (in $) in Miscellaneous expenses in 2001 to that in 2004?
Give a very brief answer. 1.05. What is the ratio of the Expenses (in $) of Labor Taxes in 2001 to that in 2004?
Give a very brief answer. 0.99. What is the ratio of the Expenses (in $) in Grants and Revenue in 2001 to that in 2004?
Provide a succinct answer. 0.94. What is the ratio of the Expenses (in $) in Miscellaneous expenses in 2001 to that in 2005?
Ensure brevity in your answer.  1.14. What is the ratio of the Expenses (in $) of Labor Taxes in 2001 to that in 2005?
Your answer should be compact. 0.86. What is the ratio of the Expenses (in $) of Services in 2001 to that in 2005?
Keep it short and to the point. 0.94. What is the ratio of the Expenses (in $) in Miscellaneous expenses in 2002 to that in 2003?
Your answer should be compact. 0.94. What is the ratio of the Expenses (in $) in Labor Taxes in 2002 to that in 2003?
Ensure brevity in your answer.  1.12. What is the ratio of the Expenses (in $) of Grants and Revenue in 2002 to that in 2003?
Provide a short and direct response. 0.93. What is the ratio of the Expenses (in $) in Services in 2002 to that in 2003?
Provide a short and direct response. 1.01. What is the ratio of the Expenses (in $) of Miscellaneous expenses in 2002 to that in 2004?
Your answer should be very brief. 0.92. What is the ratio of the Expenses (in $) of Labor Taxes in 2002 to that in 2004?
Your answer should be very brief. 1.06. What is the ratio of the Expenses (in $) of Grants and Revenue in 2002 to that in 2004?
Offer a very short reply. 0.85. What is the ratio of the Expenses (in $) in Services in 2002 to that in 2004?
Ensure brevity in your answer.  1.03. What is the ratio of the Expenses (in $) in Labor Taxes in 2002 to that in 2005?
Your response must be concise. 0.93. What is the ratio of the Expenses (in $) of Grants and Revenue in 2002 to that in 2005?
Keep it short and to the point. 0.75. What is the ratio of the Expenses (in $) in Services in 2002 to that in 2005?
Keep it short and to the point. 0.97. What is the ratio of the Expenses (in $) in Miscellaneous expenses in 2003 to that in 2004?
Provide a short and direct response. 0.98. What is the ratio of the Expenses (in $) in Labor Taxes in 2003 to that in 2004?
Give a very brief answer. 0.95. What is the ratio of the Expenses (in $) of Grants and Revenue in 2003 to that in 2004?
Keep it short and to the point. 0.91. What is the ratio of the Expenses (in $) of Services in 2003 to that in 2004?
Your response must be concise. 1.02. What is the ratio of the Expenses (in $) of Miscellaneous expenses in 2003 to that in 2005?
Your answer should be compact. 1.05. What is the ratio of the Expenses (in $) in Labor Taxes in 2003 to that in 2005?
Give a very brief answer. 0.83. What is the ratio of the Expenses (in $) in Grants and Revenue in 2003 to that in 2005?
Offer a terse response. 0.81. What is the ratio of the Expenses (in $) in Services in 2003 to that in 2005?
Provide a short and direct response. 0.97. What is the ratio of the Expenses (in $) of Miscellaneous expenses in 2004 to that in 2005?
Keep it short and to the point. 1.08. What is the ratio of the Expenses (in $) in Labor Taxes in 2004 to that in 2005?
Provide a short and direct response. 0.87. What is the ratio of the Expenses (in $) of Grants and Revenue in 2004 to that in 2005?
Give a very brief answer. 0.89. What is the ratio of the Expenses (in $) of Services in 2004 to that in 2005?
Offer a very short reply. 0.95. What is the difference between the highest and the second highest Expenses (in $) in Miscellaneous expenses?
Your answer should be very brief. 3.74e+08. What is the difference between the highest and the second highest Expenses (in $) of Labor Taxes?
Your response must be concise. 5.12e+08. What is the difference between the highest and the second highest Expenses (in $) in Grants and Revenue?
Provide a short and direct response. 1.92e+09. What is the difference between the highest and the second highest Expenses (in $) in Services?
Offer a terse response. 3.76e+08. What is the difference between the highest and the lowest Expenses (in $) in Miscellaneous expenses?
Provide a short and direct response. 1.54e+09. What is the difference between the highest and the lowest Expenses (in $) in Labor Taxes?
Provide a succinct answer. 1.19e+09. What is the difference between the highest and the lowest Expenses (in $) in Grants and Revenue?
Offer a very short reply. 6.13e+09. What is the difference between the highest and the lowest Expenses (in $) of Services?
Offer a terse response. 3.06e+09. 